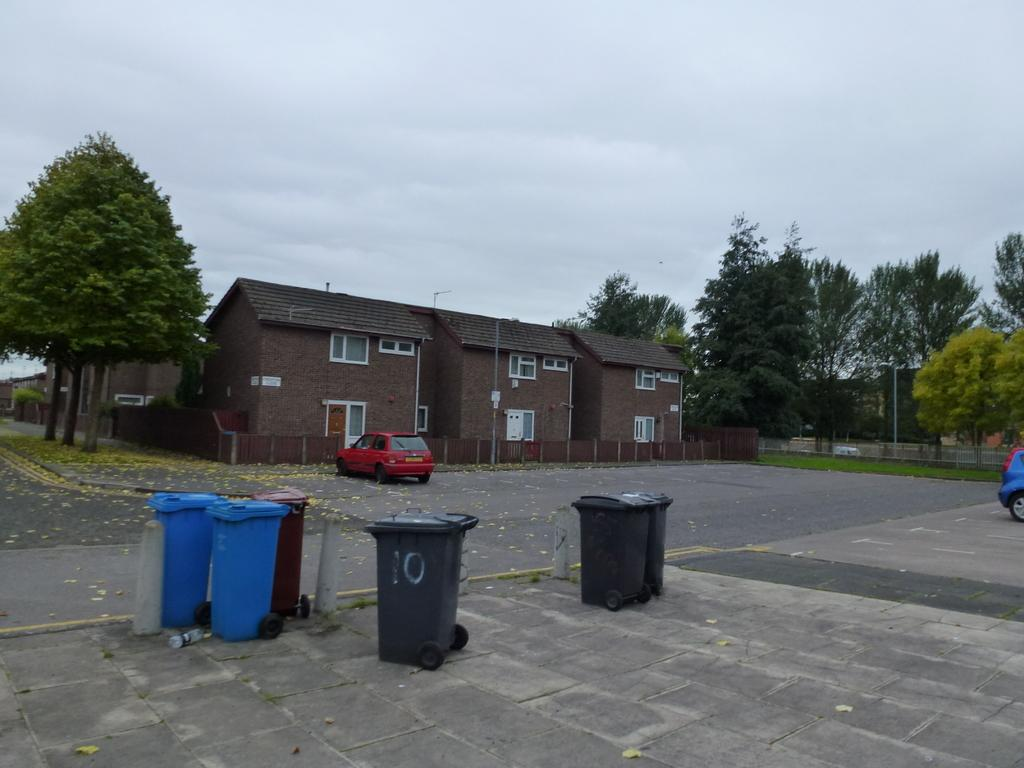<image>
Present a compact description of the photo's key features. Garbage can with the number 10 outside of a building. 